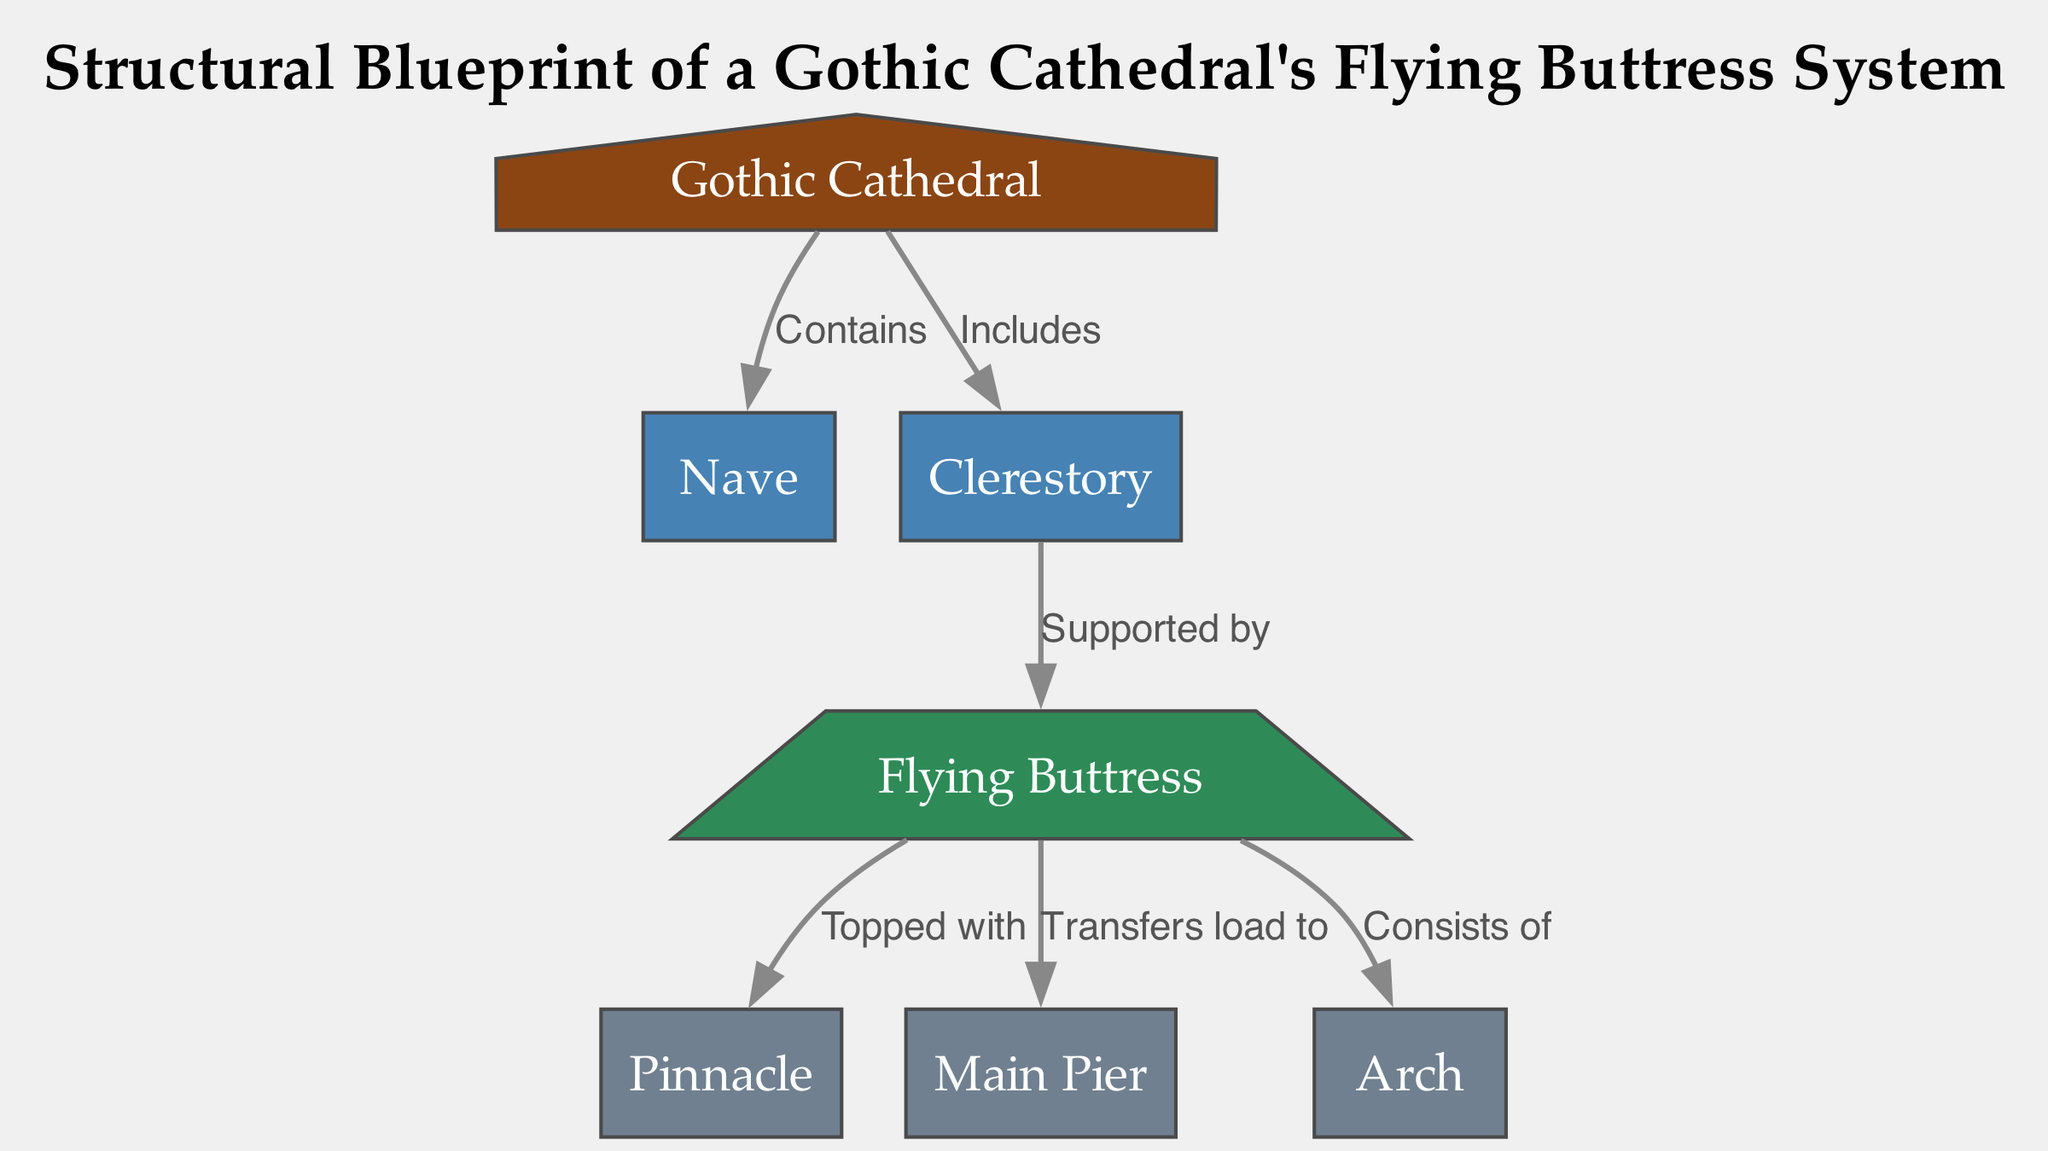How many nodes are in the diagram? The nodes listed in the data are the Gothic Cathedral, Nave, Clerestory, Flying Buttress, Pinnacle, Main Pier, and Arch, making a total of seven distinct nodes.
Answer: 7 What relationship does the buttress have with the main pier? The diagram indicates that the Flying Buttress transfers load to the Main Pier, establishing a direct relationship between the two elements in terms of structural support.
Answer: Transfers load to What is the highest element in the diagram? The Pinnacle is the element that sits atop the Flying Buttress, making it the highest element represented in the structural diagram of the Gothic cathedral.
Answer: Pinnacle What does the Clerestory support? According to the edges in the diagram, the Clerestory is supported by the Flying Buttress, signifying the vertical support provided to this part of the cathedral.
Answer: Flying Buttress How many edges are in the diagram? Counting the edges connecting the nodes, there are a total of six edges that depict the relationships between the different structural components of the Gothic cathedral.
Answer: 6 What are the components that the buttress consists of? The Flying Buttress is indicated to consist of the Arch, which is explicitly stated in the relationships shown in the diagram, thereby highlighting a key construction element.
Answer: Arch What architectural feature does the Gothic Cathedral primarily include? The diagram shows that the Gothic Cathedral includes the Clerestory, pointing to an important architectural aspect often found in these grand structures.
Answer: Clerestory What element is directly topped with a Pinnacle? The Flying Buttress is the element that is topped with the Pinnacle, indicating a design choice that both enhances aesthetic value and contributes to structural integrity.
Answer: Flying Buttress 